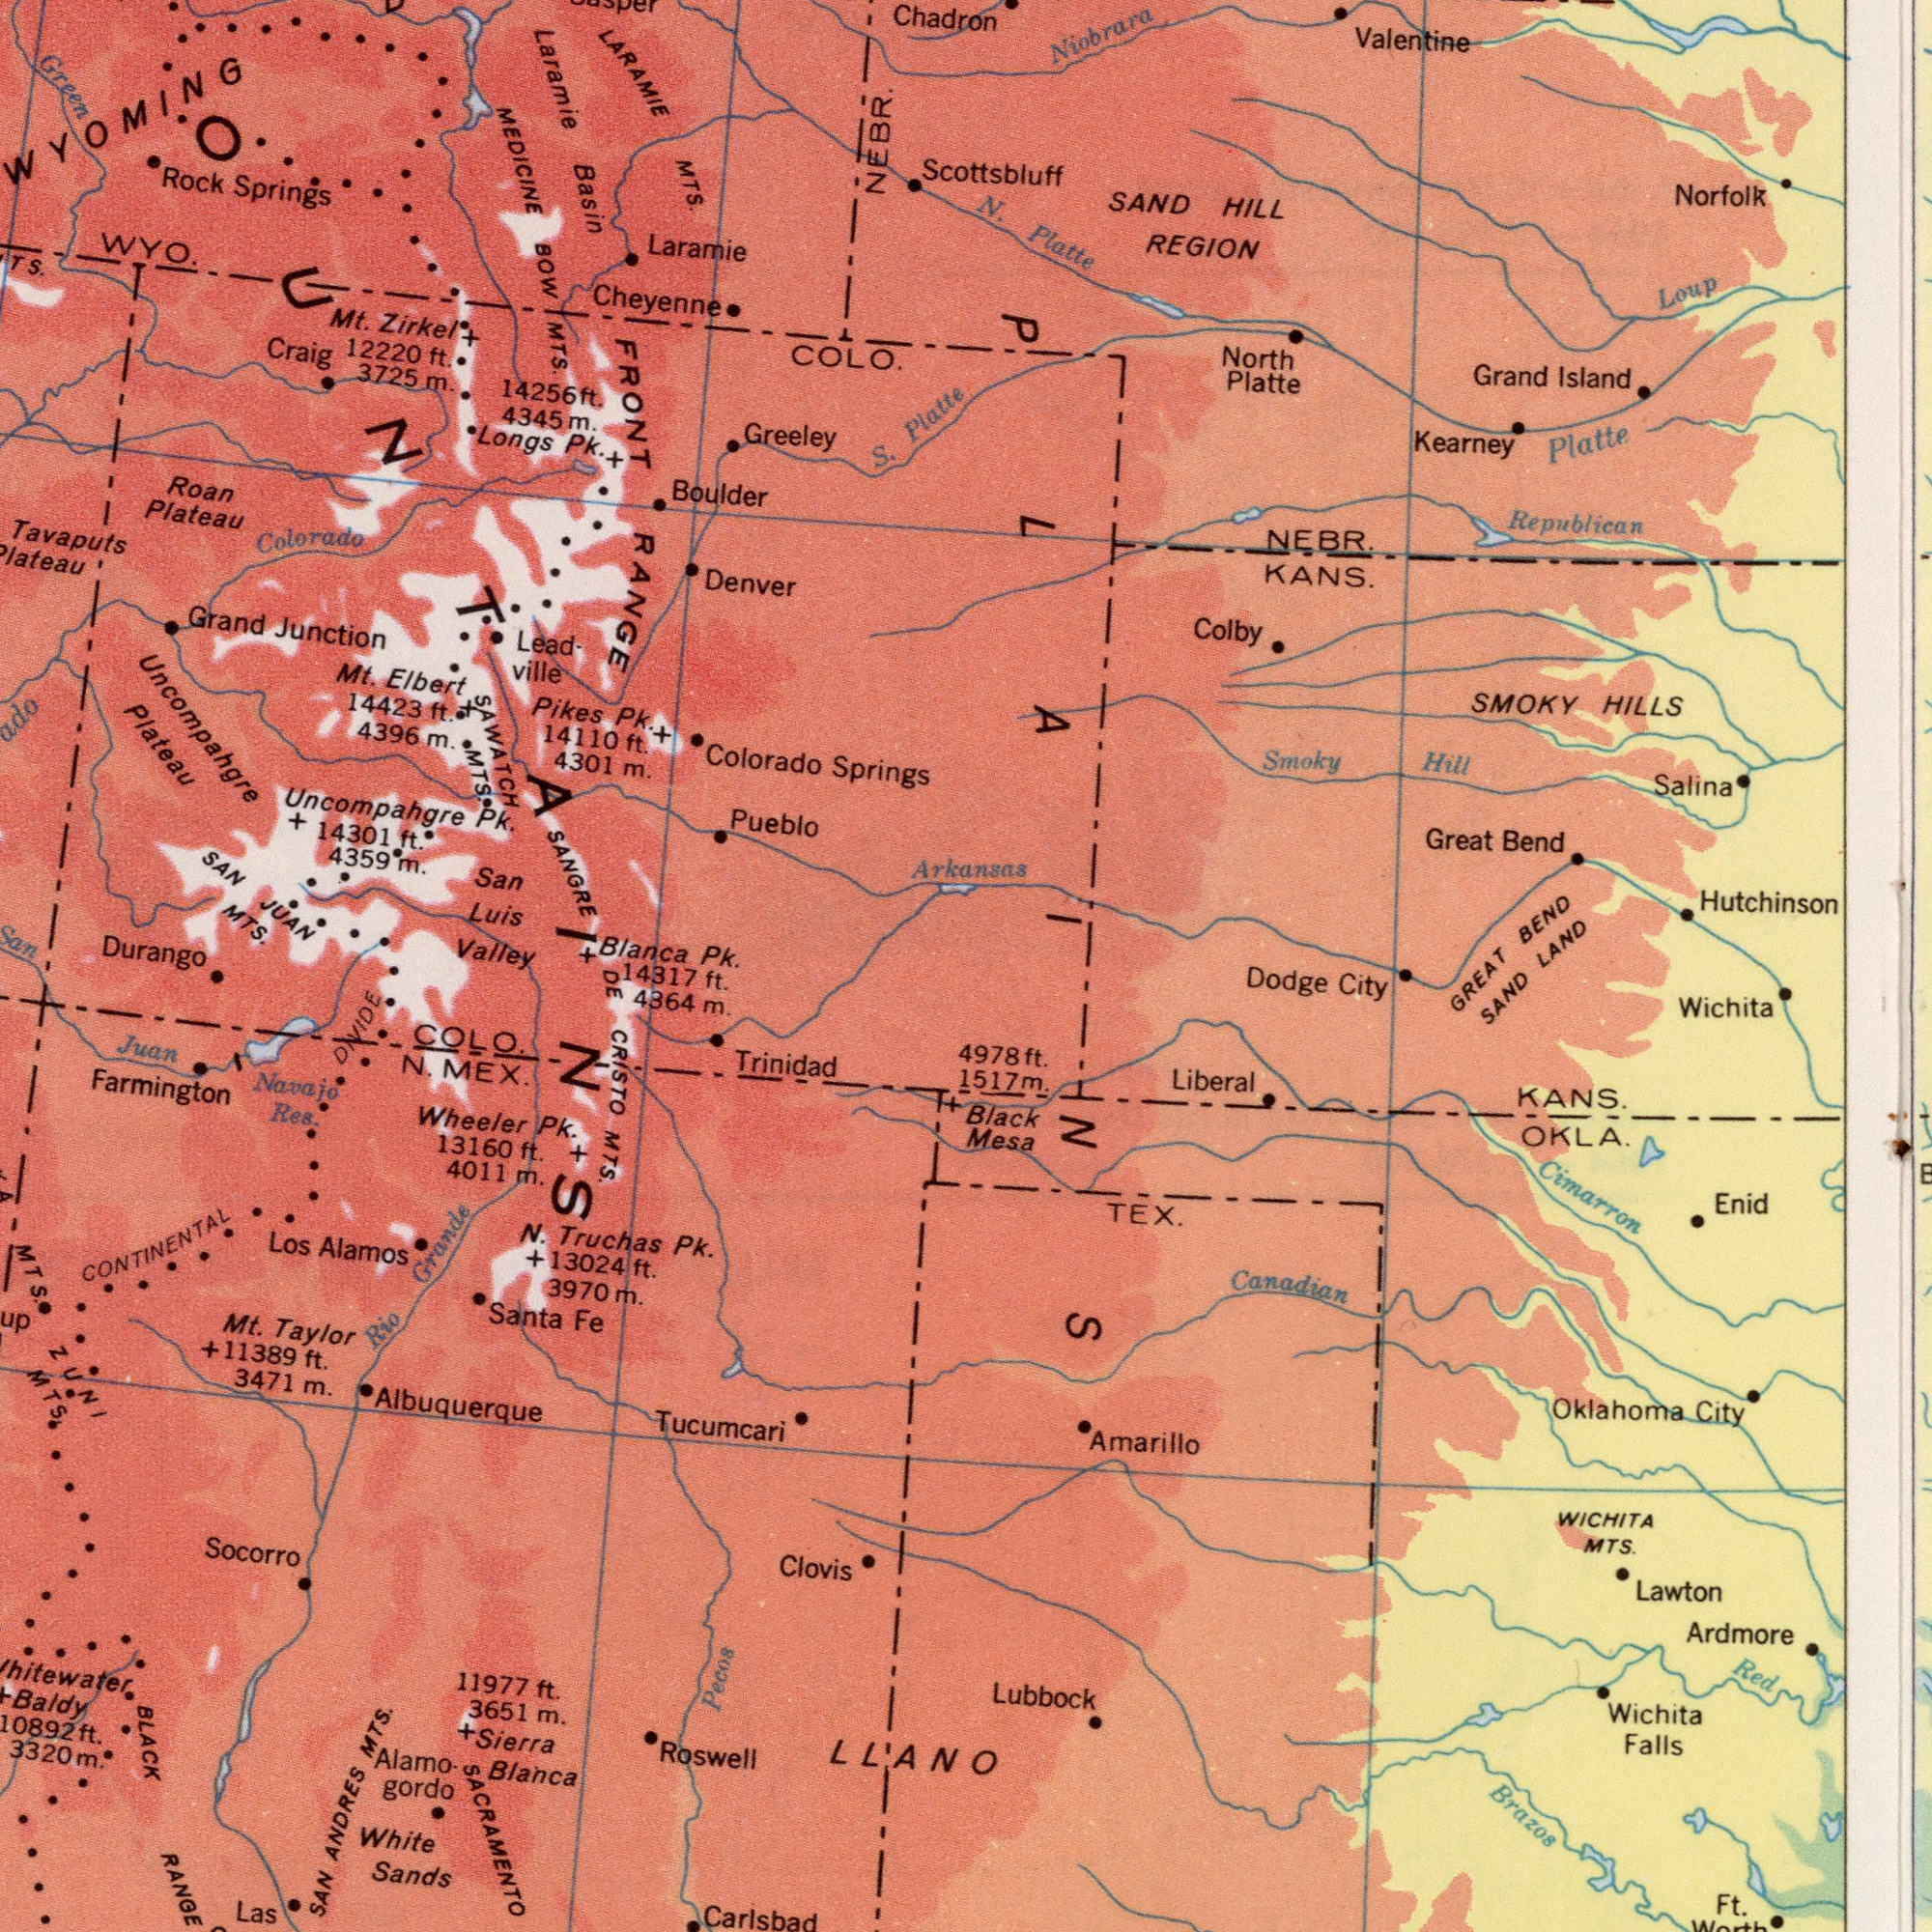What text is shown in the bottom-right quadrant? GREAT SAND Cimarron Lubbock KANS. Oklahoma City Brazos Wichita WICHITA MTS. Lawton Dodge City Liberal Canadian Amarillo Black Mesa Wichita Falls Enid Ft. Red OKLA. TEX. Ardmore 4978 ft. 1517 m. What text appears in the top-right area of the image? Chadron Platte Arkansas Hutchinson NEBR. KANS. Republican SAND HILL REGION SMOKY HILLS Norfolk Loup N. Platte Grand Island Salina Niobrara Platte Great Bend North Platte Smoky Hill BEND LAND Valentine Kearney Colby Scottsbluff PLAINS What text is shown in the top-left quadrant? MEDICINE BOW MTS. Laramie SANGRE Uncompahgre Plateau Tavaputs FRONT RANGE LARAMIE MTS. Colorado Springs COLO. Durango Laramie Mt. Elbert Colorado San Luis Valley Longs Pk. Denver Blanca Pk. Basin Greeley Cheyenne SAN JUAN MTS. Rock Springs S. Uncompahgre Pk. Roan Plateau Craig Pikes Pk. 4396 m. Boulder 4359 m. Green 3725 m. SAWATCH MTS. 4301 m. Lead ville Pueblo Grand Junction Mt. Zirkel 12220 ft. WYO. San NEBR. 14423 ft. 14301 ft. 4345 m. WYOMING 14110 ft. ###OUNTAINS 14256 ft. What text appears in the bottom-left area of the image? DE CRISTO MTS. Juan Tucumcari Farmington Roswell BLACK RANGE Clovis SAN ANDRES MTS. White Sands Albuquerque Socorro Las Carlsbad Santa Fe Sierra Blanca Alamo. gordo Los Alamos Rio Grande Trinidad 3651 m. 3471 m. Namajo Res LLANO N. Truchas Pk. 4364 m. MTS. N. MEX. Wheeler Pk. 11977 ft. Pecos DIVIDE SACRAMENTO Whitewater Baldy Mt. Taylor +11389 ft. ZUNI MTS. COLO 13024 ft. CONTINENTAL 14317 ft. 13160 ft. 10892 ft. 3320 m. 3970 m. 4011 m. 